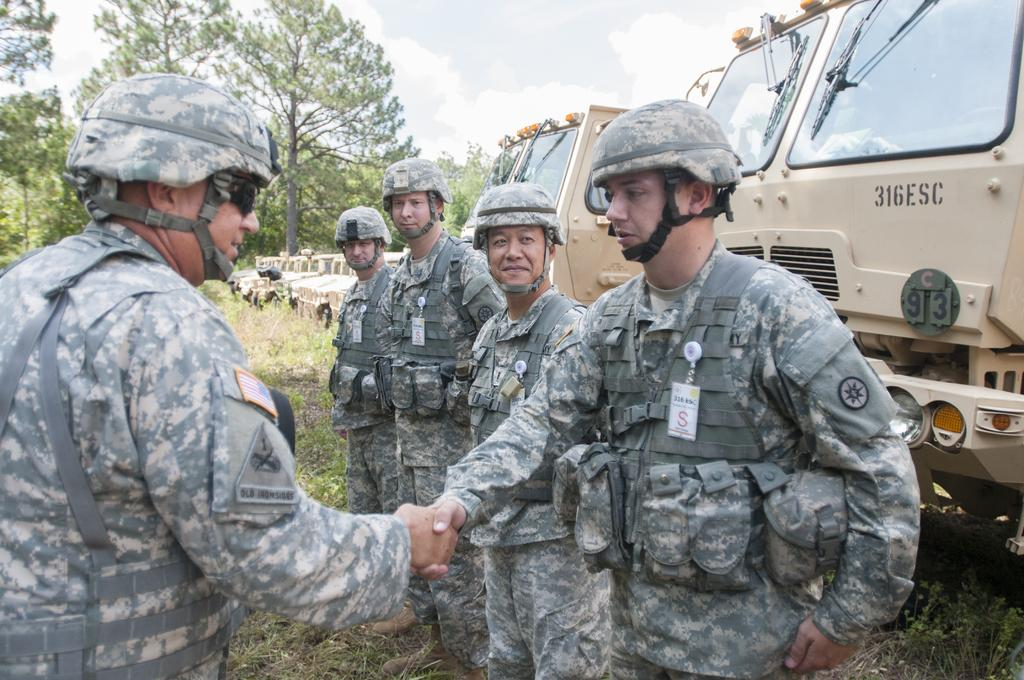<image>
Give a short and clear explanation of the subsequent image. the numbers 316 that are on the front of a truck 